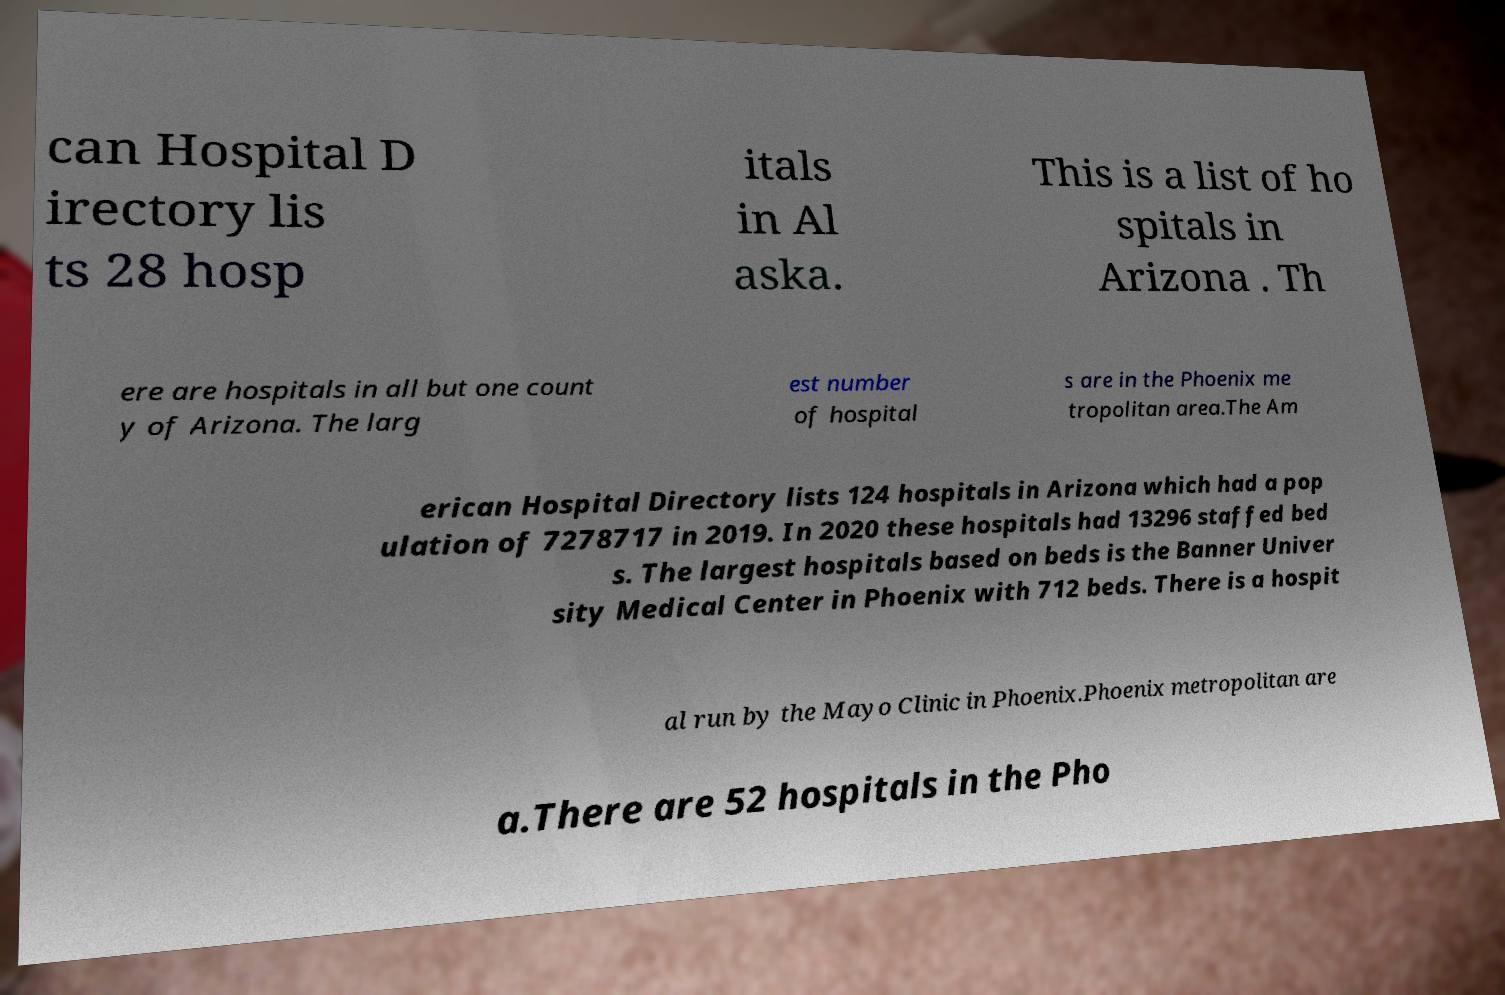For documentation purposes, I need the text within this image transcribed. Could you provide that? can Hospital D irectory lis ts 28 hosp itals in Al aska. This is a list of ho spitals in Arizona . Th ere are hospitals in all but one count y of Arizona. The larg est number of hospital s are in the Phoenix me tropolitan area.The Am erican Hospital Directory lists 124 hospitals in Arizona which had a pop ulation of 7278717 in 2019. In 2020 these hospitals had 13296 staffed bed s. The largest hospitals based on beds is the Banner Univer sity Medical Center in Phoenix with 712 beds. There is a hospit al run by the Mayo Clinic in Phoenix.Phoenix metropolitan are a.There are 52 hospitals in the Pho 